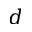Convert formula to latex. <formula><loc_0><loc_0><loc_500><loc_500>d</formula> 